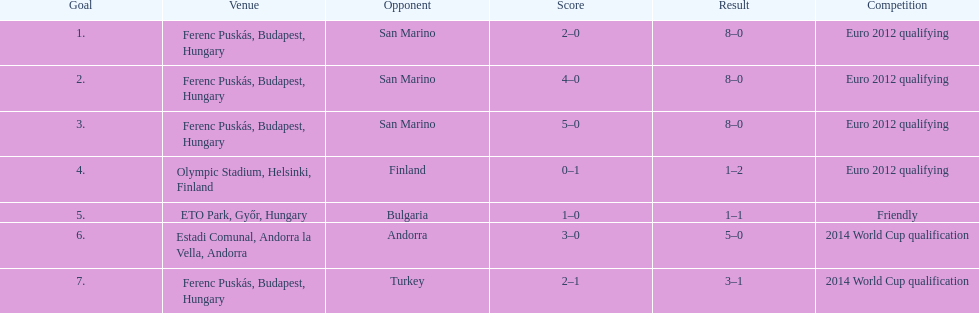In what year did ádám szalai make his next international goal after 2010? 2012. 